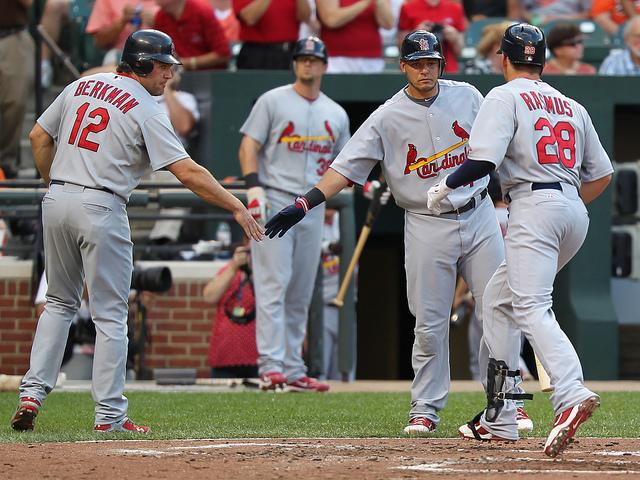What sport is this?
Keep it brief. Baseball. What team is this?
Quick response, please. Cardinals. What team do these players play for?
Answer briefly. Cardinals. What number is the player on the far right wearing?
Concise answer only. 28. What is the color of the player's uniforms?
Write a very short answer. Gray. What number is on the shirt of the man in the back left?
Keep it brief. 12. Are the players of the same team?
Concise answer only. Yes. 